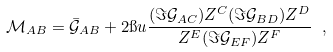Convert formula to latex. <formula><loc_0><loc_0><loc_500><loc_500>\mathcal { M } _ { A B } = \bar { \mathcal { G } } _ { A B } + 2 \i u \frac { ( \Im \mathcal { G } _ { A C } ) Z ^ { C } ( \Im \mathcal { G } _ { B D } ) Z ^ { D } } { Z ^ { E } ( \Im \mathcal { G } _ { E F } ) Z ^ { F } } \ ,</formula> 